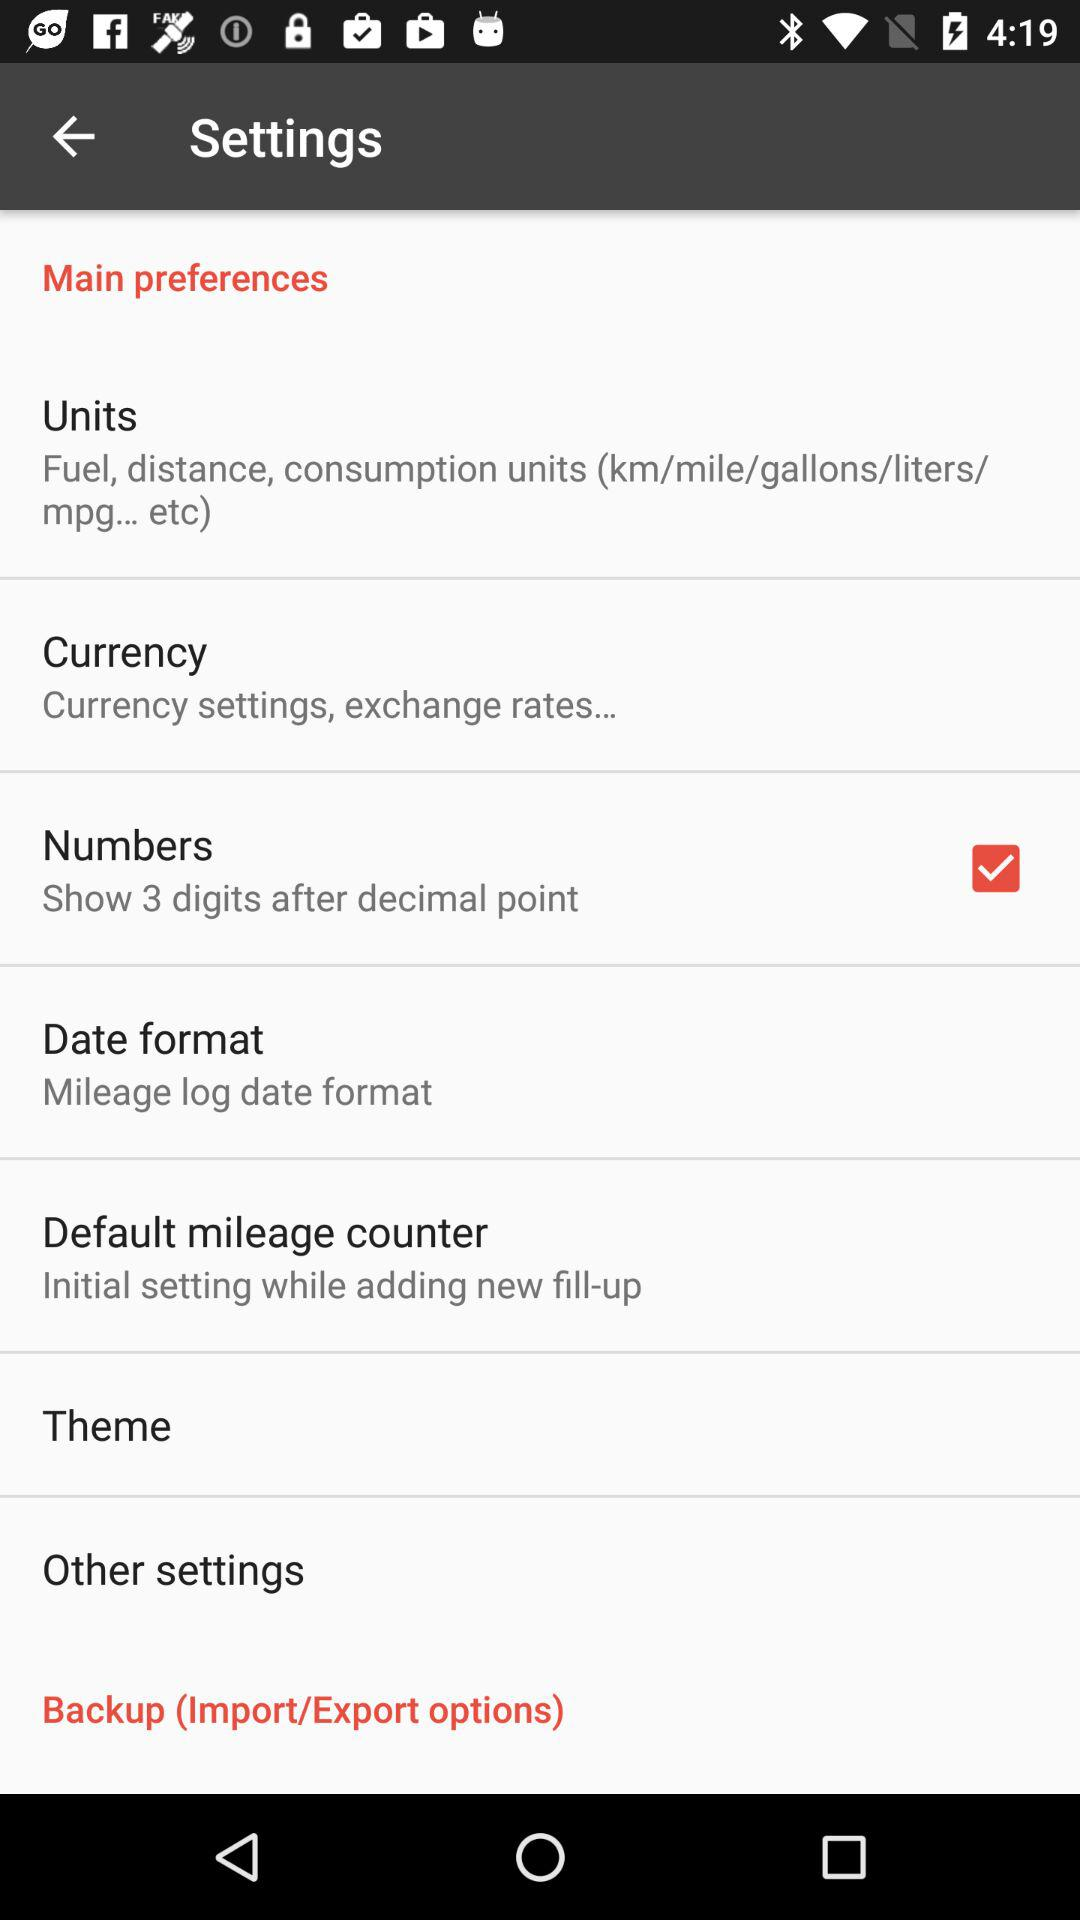What is the selected theme?
When the provided information is insufficient, respond with <no answer>. <no answer> 